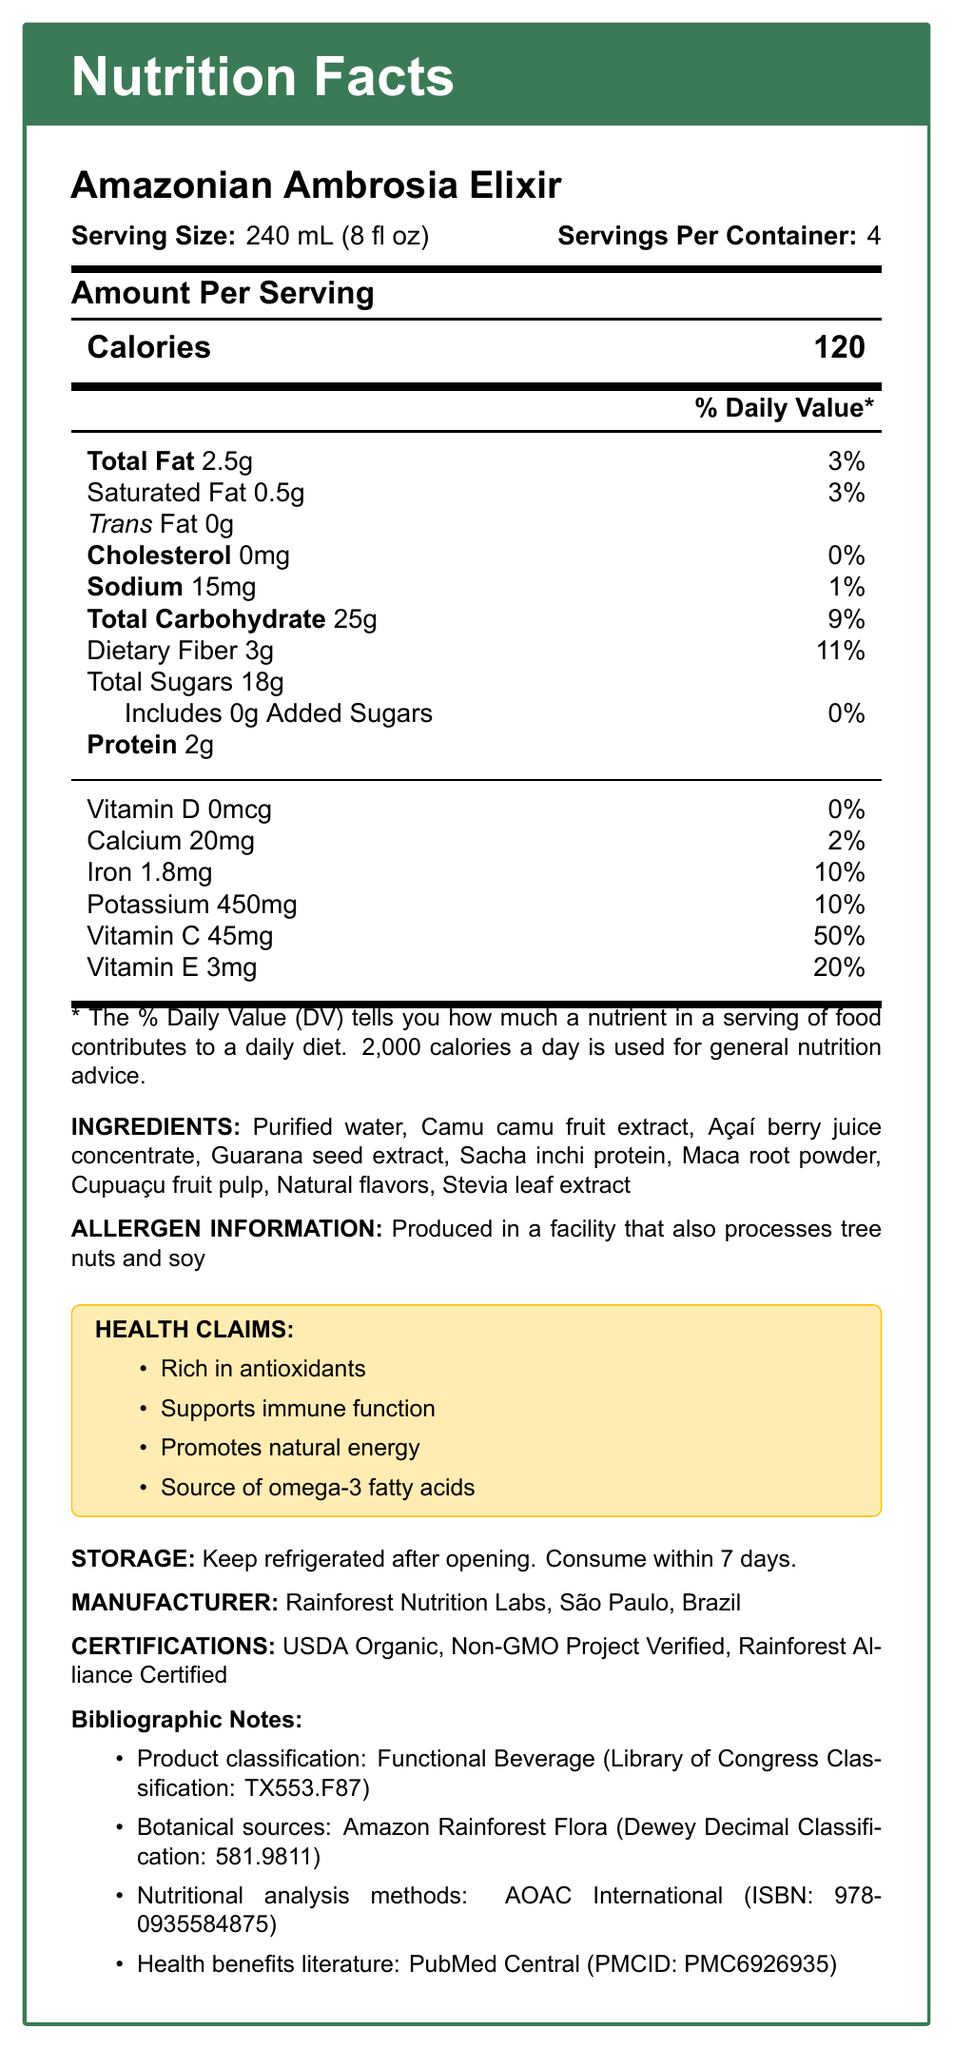what is the serving size for Amazonian Ambrosia Elixir? The serving size is mentioned in the document as 240 mL (8 fl oz).
Answer: 240 mL (8 fl oz) how many servings are there in each container? The number of servings per container is specified as 4.
Answer: 4 what is the total amount of dietary fiber per serving? The document lists the dietary fiber content per serving as 3g.
Answer: 3g what percentage of the daily value of Vitamin C does one serving provide? The document indicates that one serving provides 50% of the daily value for Vitamin C.
Answer: 50% which type of fat is absent from the Amazonian Ambrosia Elixir? The document states "Trans Fat 0g", indicating that trans fat is absent.
Answer: Trans Fat what is one of the health claims made about Amazonian Ambrosia Elixir? The document lists several health claims, including "Rich in antioxidants".
Answer: Rich in antioxidants where should the product be stored after opening? The storage instructions state, "Keep refrigerated after opening."
Answer: Refrigerated who is the manufacturer of Amazonian Ambrosia Elixir? A. Rainforest Nutrition Labs B. Amazonian Health Corp C. Green Earth Products D. Tropical Life Sciences The manufacturer is listed as Rainforest Nutrition Labs.
Answer: A. Rainforest Nutrition Labs which of the following nutrients has the highest daily value percentage per serving? A. Vitamin D B. Vitamin C C. Iron D. Calcium Vitamin C has the highest daily value percentage per serving at 50%.
Answer: B. Vitamin C is this product classified within the Dewey Decimal Classification system? The bibliographic notes section mentions a Dewey Decimal Classification number for Amazon Rainforest Flora.
Answer: Yes summarize the main nutritional benefits of the Amazonian Ambrosia Elixir This summary captures the main nutritional profile and health benefits as highlighted in the document.
Answer: The Amazonian Ambrosia Elixir is a functional beverage rich in antioxidants, supports immune function, and promotes natural energy. It contains significant amounts of Vitamin C, iron, potassium, and omega-3 fatty acids, with low levels of fat, cholesterol, and sodium. what is the ISBN for the nutritional analysis methods? The bibliographic notes section lists the ISBN for the nutritional analysis methods as 978-0935584875.
Answer: 978-0935584875 how many mg of sodium are there in one serving of Amazonian Ambrosia Elixir? The document states that each serving contains 15mg of sodium.
Answer: 15mg can the exact amount of each ingredient in the product be determined from the document? The document provides a list of ingredients but does not specify the exact amount of each ingredient.
Answer: No how long should the product be consumed after opening? The storage instructions advise consuming the product within 7 days after opening.
Answer: Within 7 days 